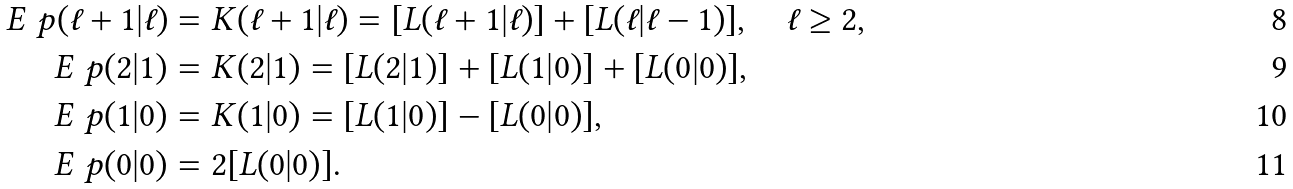Convert formula to latex. <formula><loc_0><loc_0><loc_500><loc_500>E ^ { \ } p ( \ell + 1 | \ell ) & = K ( \ell + 1 | \ell ) = [ L ( \ell + 1 | \ell ) ] + [ L ( \ell | \ell - 1 ) ] , \quad \ell \geq 2 , \\ E ^ { \ } p ( 2 | 1 ) & = K ( 2 | 1 ) = [ L ( 2 | 1 ) ] + [ L ( 1 | 0 ) ] + [ L ( 0 | 0 ) ] , \\ E ^ { \ } p ( 1 | 0 ) & = K ( 1 | 0 ) = [ L ( 1 | 0 ) ] - [ L ( 0 | 0 ) ] , \\ E ^ { \ } p ( 0 | 0 ) & = 2 [ L ( 0 | 0 ) ] .</formula> 